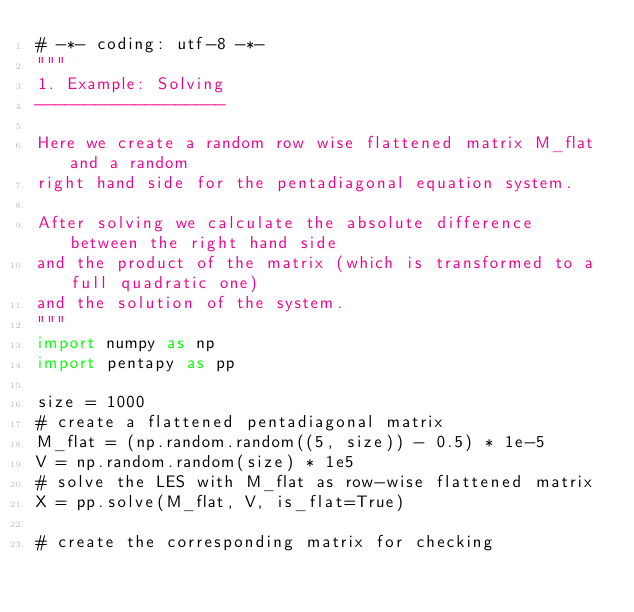<code> <loc_0><loc_0><loc_500><loc_500><_Python_># -*- coding: utf-8 -*-
"""
1. Example: Solving
-------------------

Here we create a random row wise flattened matrix M_flat and a random
right hand side for the pentadiagonal equation system.

After solving we calculate the absolute difference between the right hand side
and the product of the matrix (which is transformed to a full quadratic one)
and the solution of the system.
"""
import numpy as np
import pentapy as pp

size = 1000
# create a flattened pentadiagonal matrix
M_flat = (np.random.random((5, size)) - 0.5) * 1e-5
V = np.random.random(size) * 1e5
# solve the LES with M_flat as row-wise flattened matrix
X = pp.solve(M_flat, V, is_flat=True)

# create the corresponding matrix for checking</code> 